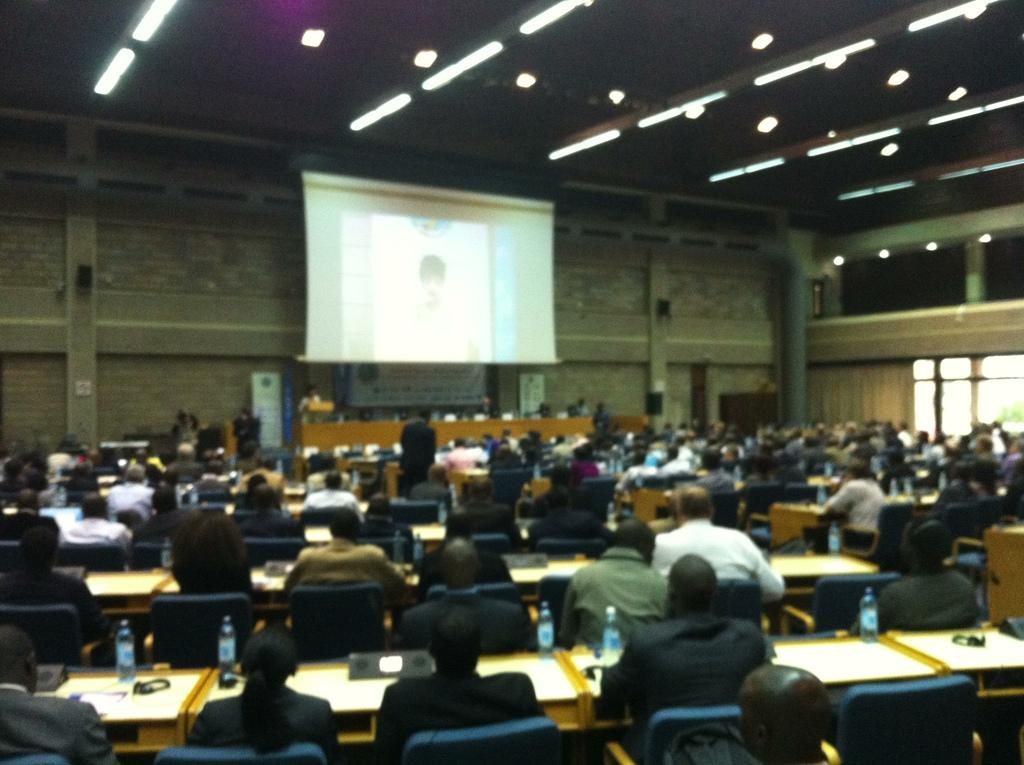What is located at the top of the image? There are lights visible at the top of the image. What are the people in the image doing? People are sitting on chairs. What is in front of the chairs? There are tables in front of the chairs. What can be found on the tables? Bottles and other objects are present on the tables. What is the purpose of the screen in the image? The screen is visible in the image, but its purpose is not specified. What type of quarter is being used to stir the stew on the table? There is no stew or quarter present in the image. Is the rifle being used by anyone in the image? There is no rifle present in the image. 